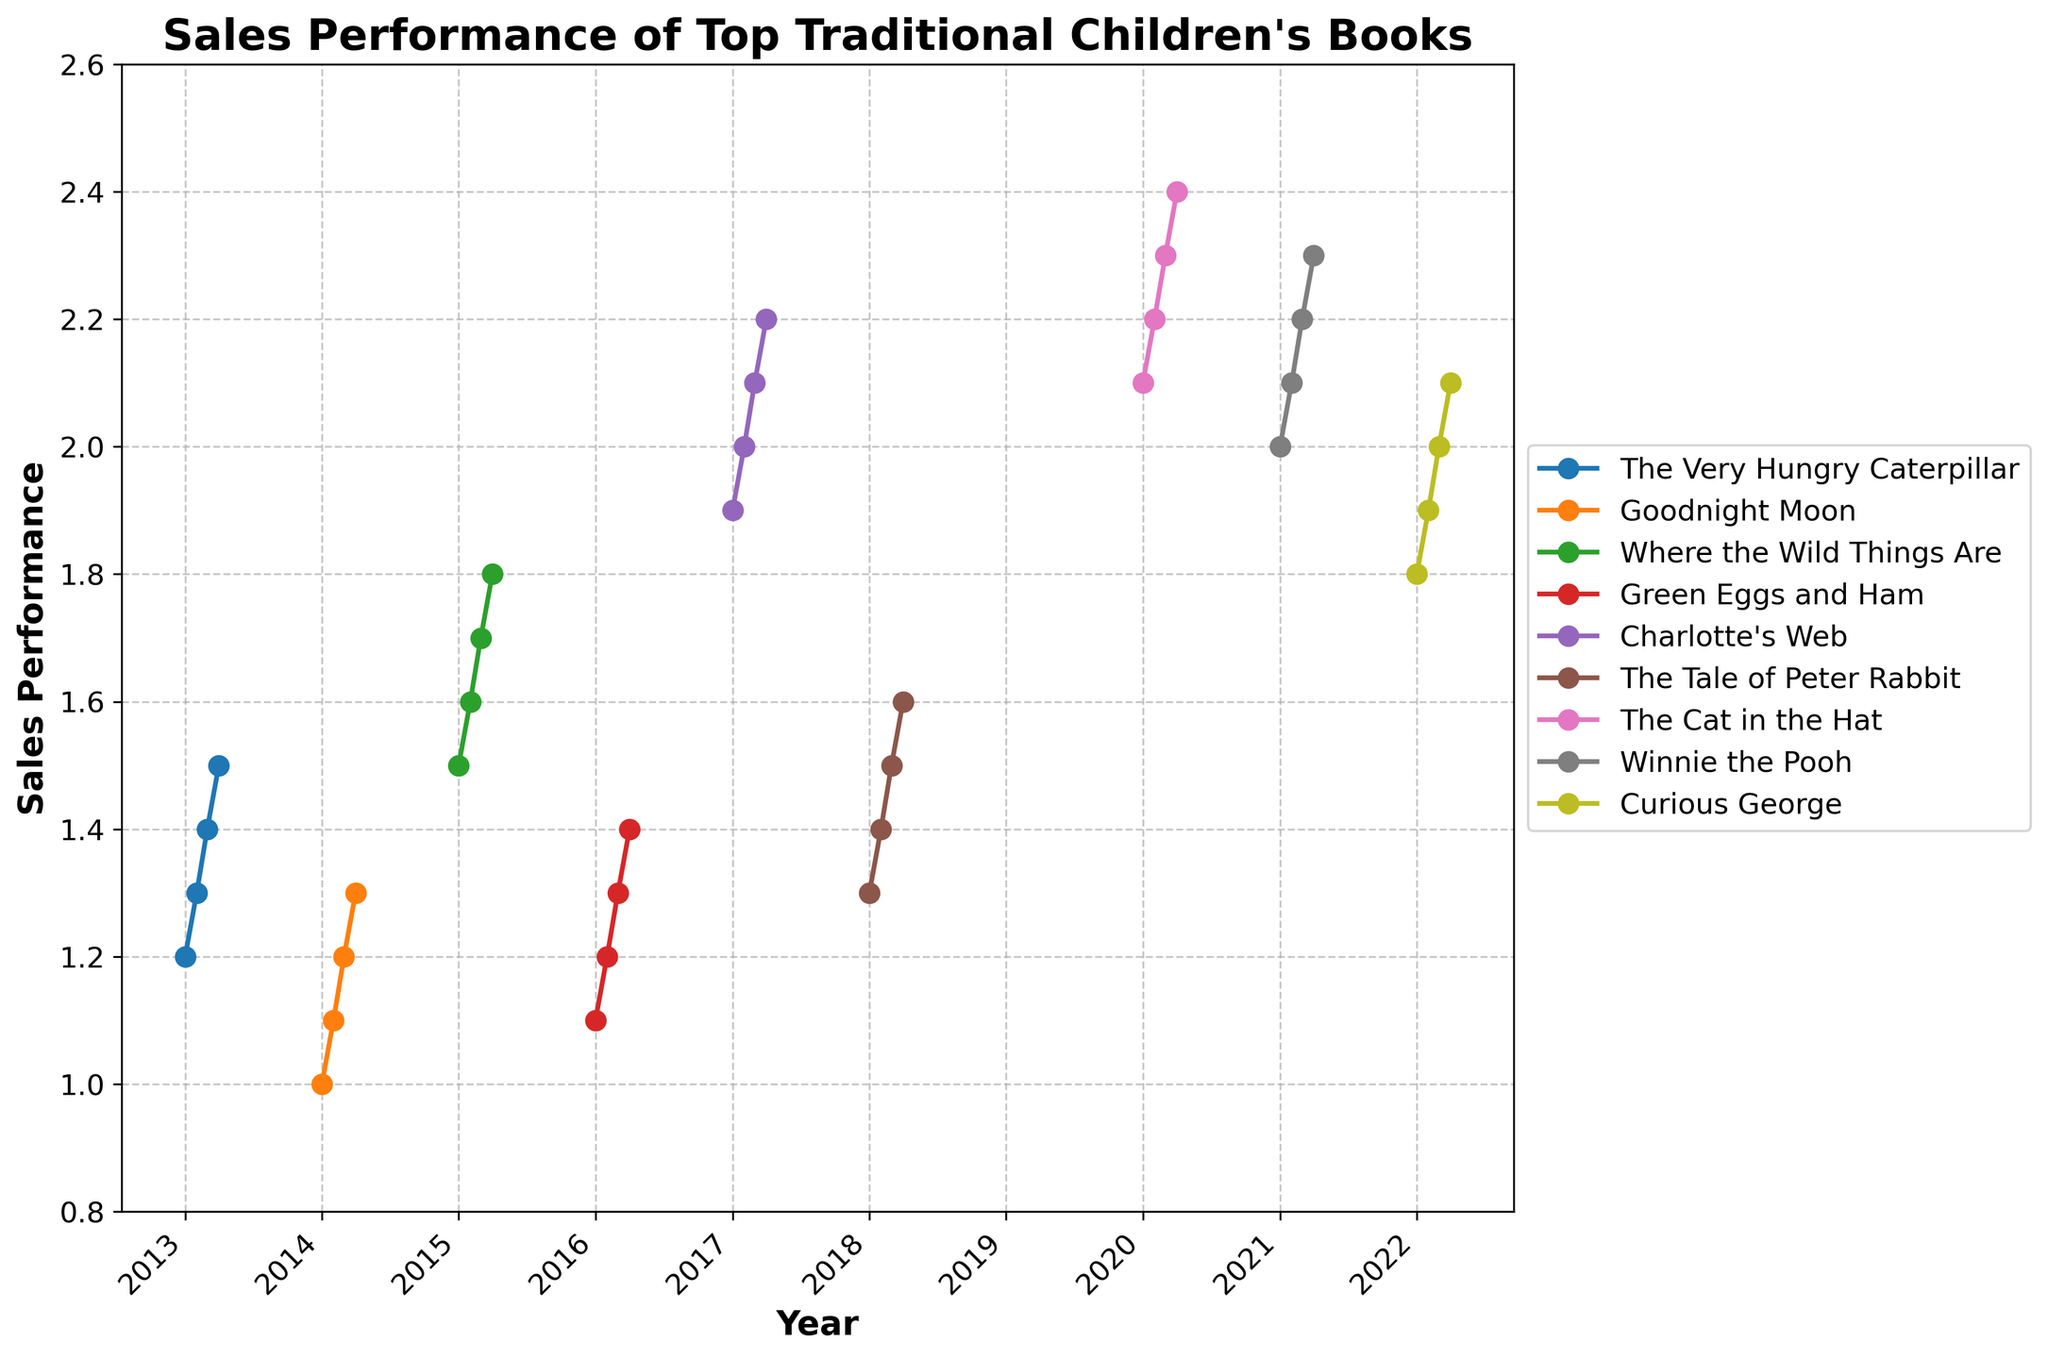What is the title of the plot? The title of the plot is often located at the top of the figure and is displayed prominently.
Answer: Sales Performance of Top Traditional Children's Books What is the time range covered in the plot? By examining the x-axis labels, you can determine the starting and ending years. The data starts in 2013 and the last point is in 2022.
Answer: 2013-2022 Which book showed the highest sales performance in a single quarter? To find this, look for the peak value on the y-axis and identify which book's line reaches that value. 'The Cat in the Hat' peaks at 2.4 in one quarter of 2020.
Answer: The Cat in the Hat Between which years did 'Charlotte's Web' show sales performance, and how did it trend overall? Find the line related to 'Charlotte's Web,' which spans from the start to end year (2017). Then, observe the line's direction from the first to the last data point. It starts at 1.9 in 2017 Q1 and steadily increases to 2.2 in 2017 Q4.
Answer: 2017; Increasing What's the average sales performance of 'Curious George' for the year 2022? Add the quarterly sales data for 'Curious George' and divide by the number of quarters. (1.8 + 1.9 + 2.0 + 2.1)/4 = 1.95
Answer: 1.95 Which book showed the greatest increase in sales performance from its Q1 to Q4? Calculate the difference between Q1 and Q4 sales for each book and determine which difference is greatest. 'The Cat in the Hat' increases from 2.1 to 2.4, which is a difference of 0.3.
Answer: The Cat in the Hat In which year did 'Where the Wild Things Are' show the highest sales performance? Locate the 'Where the Wild Things Are' line and find its highest point. The highest value of 1.8 occurs in 2015 Q4.
Answer: 2015 Compare the sales trends of 'Green Eggs and Ham' and 'Goodnight Moon' in their respective years. Which book showed a more consistent increase? Look at the sales performance across quarters for both books. 'Green Eggs and Ham' (2016) has a consistent increase from 1.1 to 1.4, whereas 'Goodnight Moon' (2014) goes from 1.0 to 1.3. 'Green Eggs and Ham' shows a consistent 0.1 increase per quarter.
Answer: Green Eggs and Ham What is the sales performance range for 'Winnie the Pooh' in 2021? Identify the minimum and maximum sales values for 'Winnie the Pooh' in 2021. The values range from 2.0 in Q1 to 2.3 in Q4.
Answer: 2.0-2.3 Which book had sales data for the greatest number of distinct years and how many years were covered? Count distinct years with data points for each book. 'The Very Hungry Caterpillar' has data points spanning one year (2013). Only one book, so the answer is 'The Very Hungry Caterpillar'.
Answer: The Very Hungry Caterpillar, 1 year 